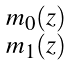<formula> <loc_0><loc_0><loc_500><loc_500>\begin{smallmatrix} m _ { 0 } \left ( z \right ) \\ m _ { 1 } \left ( z \right ) \end{smallmatrix}</formula> 